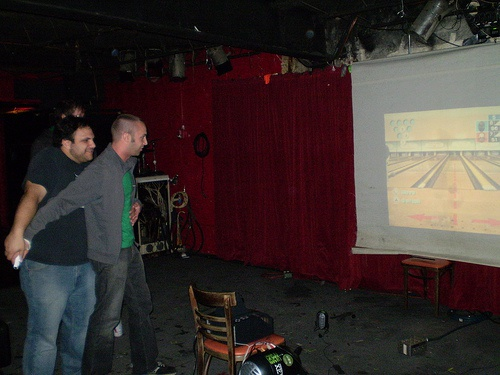Describe the objects in this image and their specific colors. I can see tv in black, darkgray, tan, and gray tones, people in black, gray, teal, and brown tones, people in black, gray, and blue tones, chair in black, maroon, and gray tones, and people in black, maroon, and brown tones in this image. 